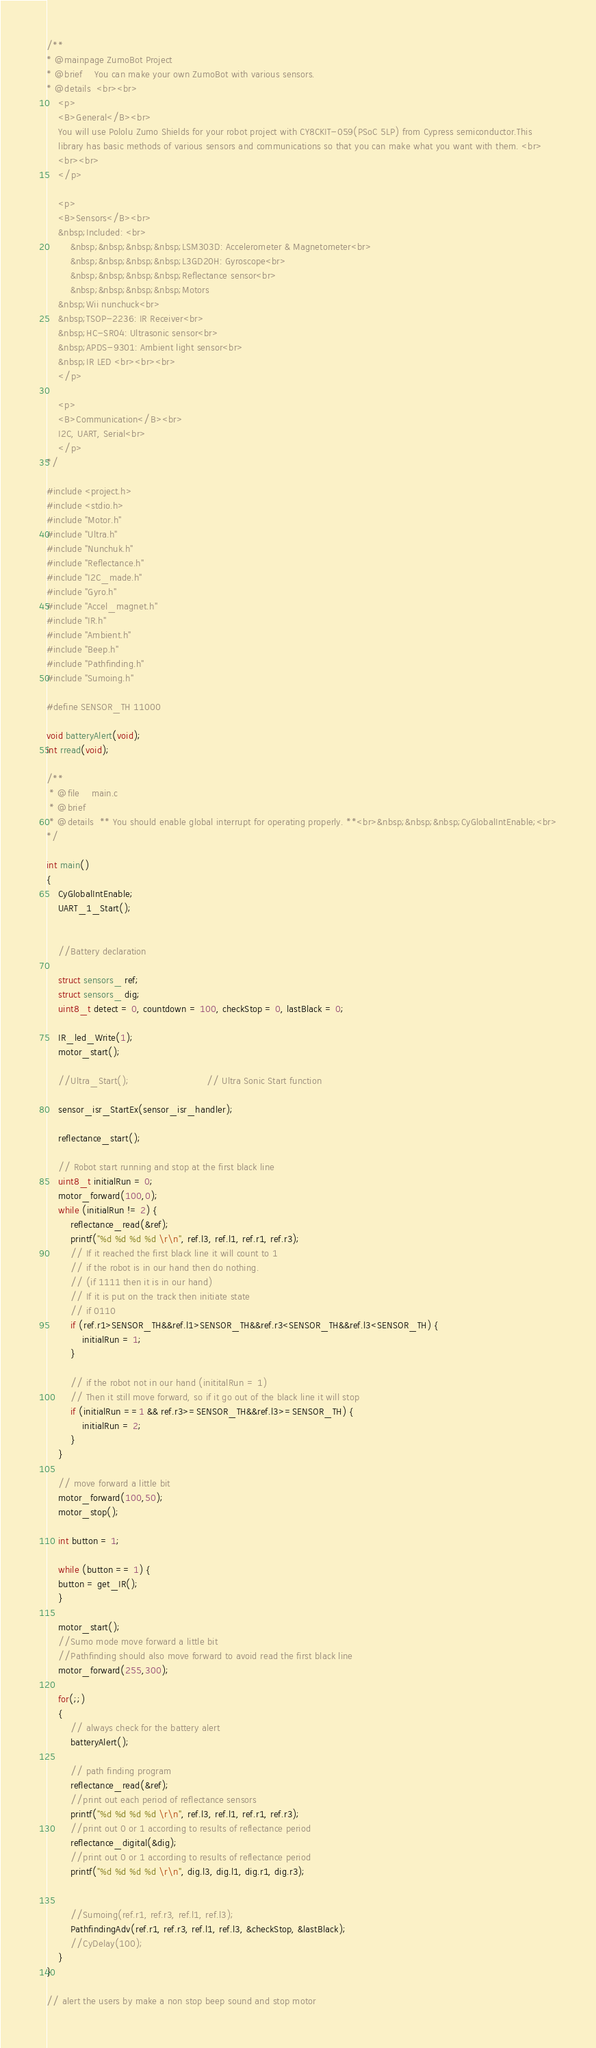<code> <loc_0><loc_0><loc_500><loc_500><_C_>/**
* @mainpage ZumoBot Project
* @brief    You can make your own ZumoBot with various sensors.
* @details  <br><br>
    <p>
    <B>General</B><br>
    You will use Pololu Zumo Shields for your robot project with CY8CKIT-059(PSoC 5LP) from Cypress semiconductor.This 
    library has basic methods of various sensors and communications so that you can make what you want with them. <br> 
    <br><br>
    </p>
    
    <p>
    <B>Sensors</B><br>
    &nbsp;Included: <br>
        &nbsp;&nbsp;&nbsp;&nbsp;LSM303D: Accelerometer & Magnetometer<br>
        &nbsp;&nbsp;&nbsp;&nbsp;L3GD20H: Gyroscope<br>
        &nbsp;&nbsp;&nbsp;&nbsp;Reflectance sensor<br>
        &nbsp;&nbsp;&nbsp;&nbsp;Motors
    &nbsp;Wii nunchuck<br>
    &nbsp;TSOP-2236: IR Receiver<br>
    &nbsp;HC-SR04: Ultrasonic sensor<br>
    &nbsp;APDS-9301: Ambient light sensor<br>
    &nbsp;IR LED <br><br><br>
    </p>
    
    <p>
    <B>Communication</B><br>
    I2C, UART, Serial<br>
    </p>
*/

#include <project.h>
#include <stdio.h>
#include "Motor.h"
#include "Ultra.h"
#include "Nunchuk.h"
#include "Reflectance.h"
#include "I2C_made.h"
#include "Gyro.h"
#include "Accel_magnet.h"
#include "IR.h"
#include "Ambient.h"
#include "Beep.h"
#include "Pathfinding.h"
#include "Sumoing.h"

#define SENSOR_TH 11000

void batteryAlert(void);
int rread(void);

/**
 * @file    main.c
 * @brief   
 * @details  ** You should enable global interrupt for operating properly. **<br>&nbsp;&nbsp;&nbsp;CyGlobalIntEnable;<br>
*/

int main()
{
    CyGlobalIntEnable; 
    UART_1_Start();       
    
    
    //Battery declaration
    
    struct sensors_ ref;
    struct sensors_ dig;  
    uint8_t detect = 0, countdown = 100, checkStop = 0, lastBlack = 0;
        
    IR_led_Write(1);
    motor_start();
    
    //Ultra_Start();                          // Ultra Sonic Start function    
    
    sensor_isr_StartEx(sensor_isr_handler);   
    
    reflectance_start();
    
    // Robot start running and stop at the first black line
    uint8_t initialRun = 0;    
    motor_forward(100,0);
    while (initialRun != 2) {
        reflectance_read(&ref);
        printf("%d %d %d %d \r\n", ref.l3, ref.l1, ref.r1, ref.r3);
        // If it reached the first black line it will count to 1
        // if the robot is in our hand then do nothing.
        // (if 1111 then it is in our hand)
        // If it is put on the track then initiate state
        // if 0110
        if (ref.r1>SENSOR_TH&&ref.l1>SENSOR_TH&&ref.r3<SENSOR_TH&&ref.l3<SENSOR_TH) {
            initialRun = 1;
        }
        
        // if the robot not in our hand (inititalRun = 1)
        // Then it still move forward, so if it go out of the black line it will stop
        if (initialRun ==1 && ref.r3>=SENSOR_TH&&ref.l3>=SENSOR_TH) {
            initialRun = 2;
        }
    }
    
    // move forward a little bit
    motor_forward(100,50);
    motor_stop();
    
    int button = 1;
    
    while (button == 1) {
    button = get_IR();
    }
    
    motor_start();
    //Sumo mode move forward a little bit
    //Pathfinding should also move forward to avoid read the first black line
    motor_forward(255,300);
    
    for(;;)
    {   
        // always check for the battery alert
        batteryAlert();
        
        // path finding program     
        reflectance_read(&ref);
        //print out each period of reflectance sensors
        printf("%d %d %d %d \r\n", ref.l3, ref.l1, ref.r1, ref.r3);
        //print out 0 or 1 according to results of reflectance period
        reflectance_digital(&dig);
        //print out 0 or 1 according to results of reflectance period
        printf("%d %d %d %d \r\n", dig.l3, dig.l1, dig.r1, dig.r3);       
        
                
        //Sumoing(ref.r1, ref.r3, ref.l1, ref.l3);        
        PathfindingAdv(ref.r1, ref.r3, ref.l1, ref.l3, &checkStop, &lastBlack);
        //CyDelay(100);
    }
}   

// alert the users by make a non stop beep sound and stop motor</code> 